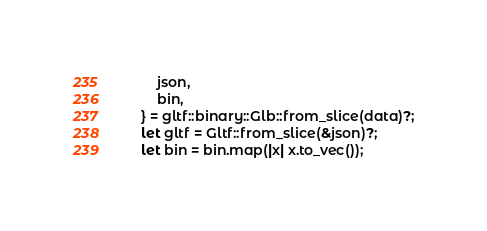Convert code to text. <code><loc_0><loc_0><loc_500><loc_500><_Rust_>        json,
        bin,
    } = gltf::binary::Glb::from_slice(data)?;
    let gltf = Gltf::from_slice(&json)?;
    let bin = bin.map(|x| x.to_vec());</code> 